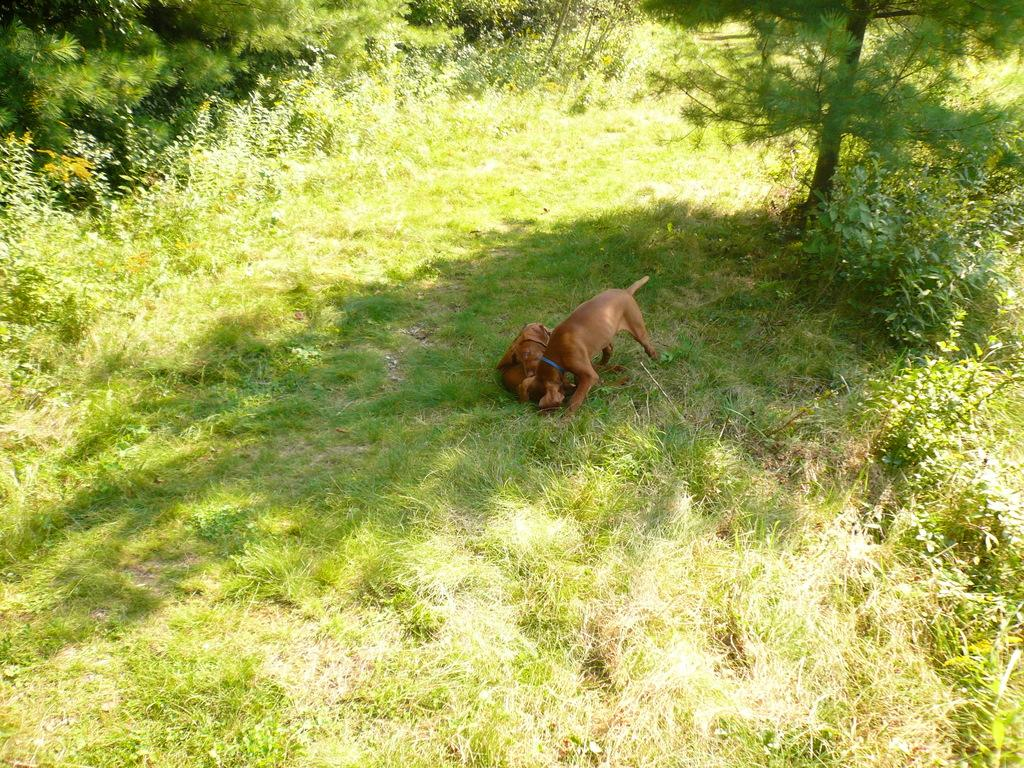What type of animals are present in the image? There are dogs in the image. What type of vegetation can be seen in the image? There is grass and trees in the image. What letter is being used by the dogs to communicate in the image? There are no letters present in the image, and dogs do not use letters to communicate. 